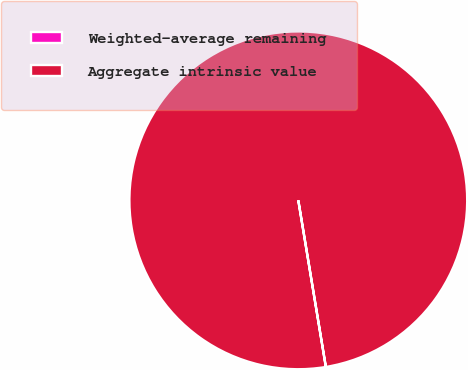Convert chart to OTSL. <chart><loc_0><loc_0><loc_500><loc_500><pie_chart><fcel>Weighted-average remaining<fcel>Aggregate intrinsic value<nl><fcel>0.0%<fcel>100.0%<nl></chart> 